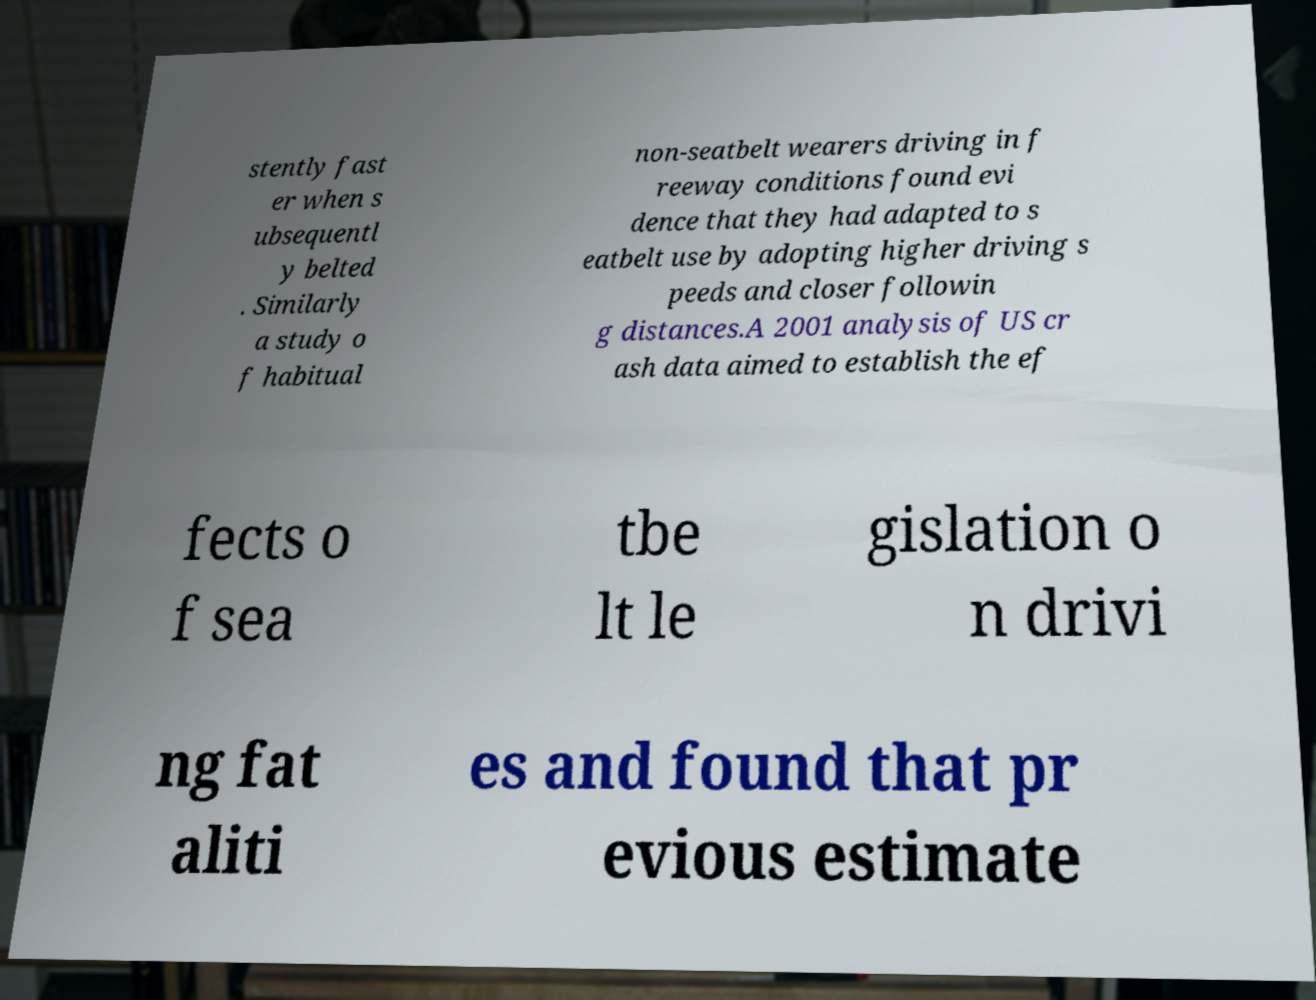Can you accurately transcribe the text from the provided image for me? stently fast er when s ubsequentl y belted . Similarly a study o f habitual non-seatbelt wearers driving in f reeway conditions found evi dence that they had adapted to s eatbelt use by adopting higher driving s peeds and closer followin g distances.A 2001 analysis of US cr ash data aimed to establish the ef fects o f sea tbe lt le gislation o n drivi ng fat aliti es and found that pr evious estimate 